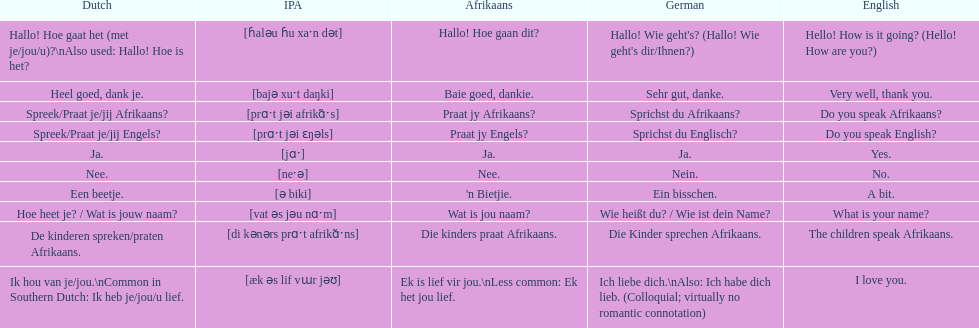Translate the following into english: 'n bietjie. A bit. 